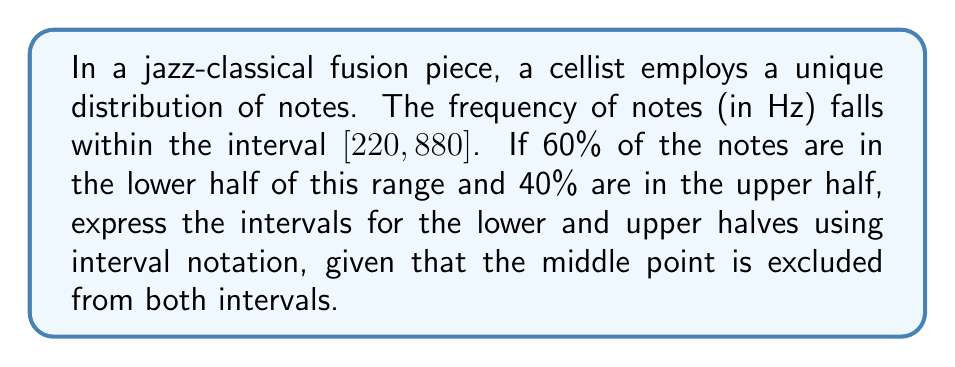Can you answer this question? 1) First, let's identify the endpoints of the total interval:
   Lower endpoint: 220 Hz
   Upper endpoint: 880 Hz

2) Calculate the midpoint of the interval:
   $\text{Midpoint} = \frac{220 + 880}{2} = 550$ Hz

3) The lower half interval will be from 220 Hz up to, but not including, 550 Hz.
   In interval notation, this is written as $[220, 550)$

4) The upper half interval will be from just above 550 Hz up to and including 880 Hz.
   In interval notation, this is written as $(550, 880]$

5) We can now express the distribution of notes:
   60% of notes are in the interval $[220, 550)$
   40% of notes are in the interval $(550, 880]$

6) To verify, note that these intervals are mutually exclusive (they don't overlap) and their union covers the entire original interval $[220, 880]$, excluding only the single point 550 Hz.
Answer: Lower half: $[220, 550)$, Upper half: $(550, 880]$ 